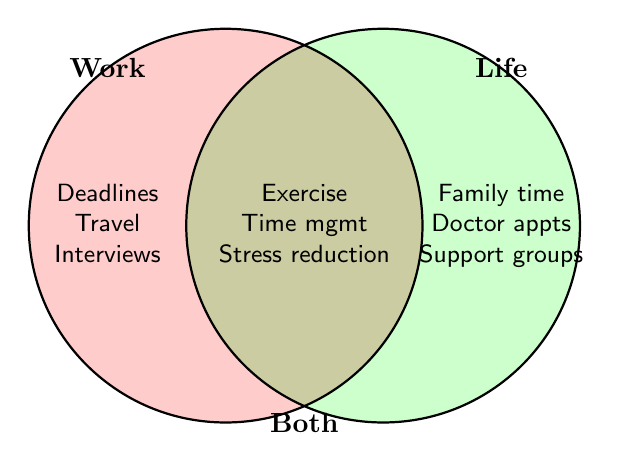What elements are listed under "Work"? The elements listed under "Work" in the Venn Diagram are: Deadlines, Travel, and Interviews. These are located in the left circle.
Answer: Deadlines, Travel, Interviews What are the elements common to both "Work" and "Life"? The overlapping section of the Venn Diagram, which represents elements common to both "Work" and "Life", includes: Exercise, Time management, and Stress reduction.
Answer: Exercise, Time management, Stress reduction How many elements are specific to "Life"? The elements that are specific to "Life" and appear only in the right circle are: Family time, Doctor appointments, and Support groups. Counting these elements gives us three.
Answer: 3 Which elements are unique to "Work" compared to those in "Life"? To identify the unique elements of "Work", we look at the left circle, which includes Deadlines, Travel, and Interviews. None of these elements appear in the right circle (Life).
Answer: Deadlines, Travel, Interviews How many strategies are related to "Both" work and life? The section of the diagram where both circles overlap includes three strategies: Exercise, Time management, and Stress reduction. Therefore, three strategies are related to both work and life.
Answer: 3 